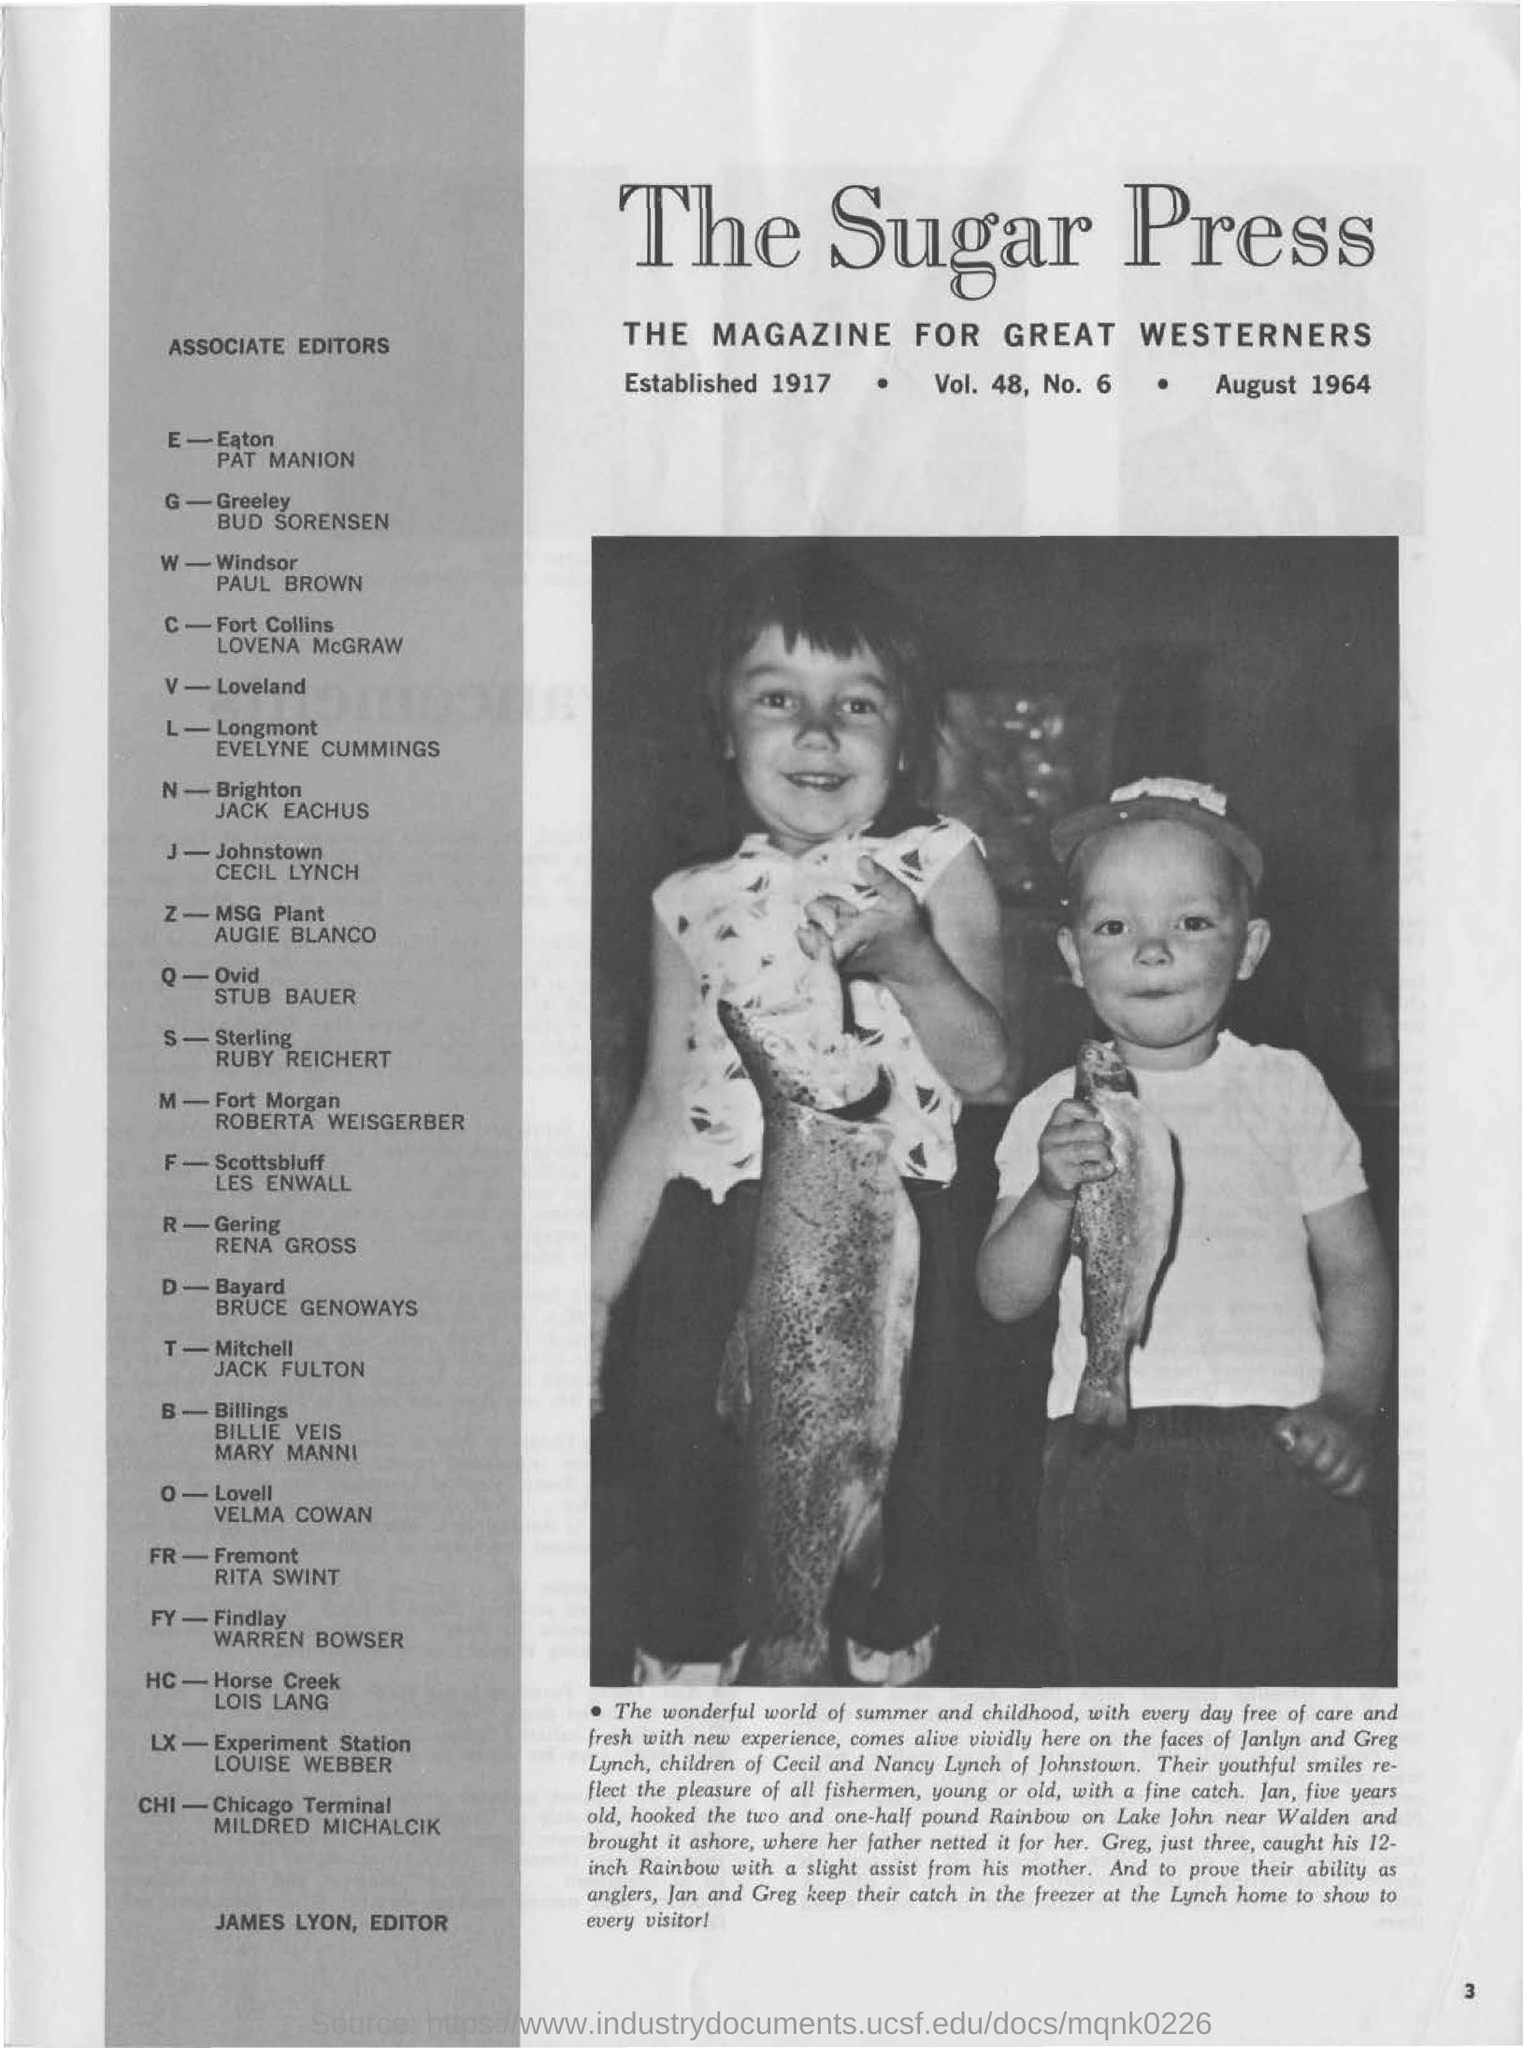What does the bold heading read?
Ensure brevity in your answer.  THE SUGAR PRESS. Who is this magaize for?
Offer a terse response. GREAT WESTERNERS. What is the age of Greg?
Provide a short and direct response. Three. Whos is the associate editor for  Brighton?
Your answer should be very brief. JACK EACHUS. 